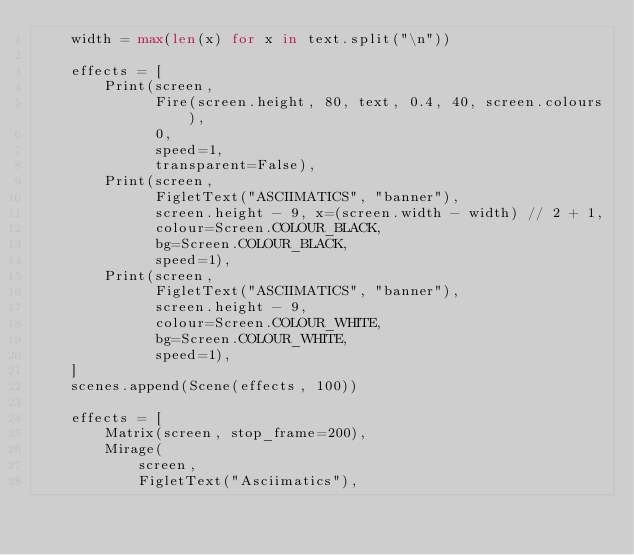Convert code to text. <code><loc_0><loc_0><loc_500><loc_500><_Python_>    width = max(len(x) for x in text.split("\n"))

    effects = [
        Print(screen,
              Fire(screen.height, 80, text, 0.4, 40, screen.colours),
              0,
              speed=1,
              transparent=False),
        Print(screen,
              FigletText("ASCIIMATICS", "banner"),
              screen.height - 9, x=(screen.width - width) // 2 + 1,
              colour=Screen.COLOUR_BLACK,
              bg=Screen.COLOUR_BLACK,
              speed=1),
        Print(screen,
              FigletText("ASCIIMATICS", "banner"),
              screen.height - 9,
              colour=Screen.COLOUR_WHITE,
              bg=Screen.COLOUR_WHITE,
              speed=1),
    ]
    scenes.append(Scene(effects, 100))

    effects = [
        Matrix(screen, stop_frame=200),
        Mirage(
            screen,
            FigletText("Asciimatics"),</code> 